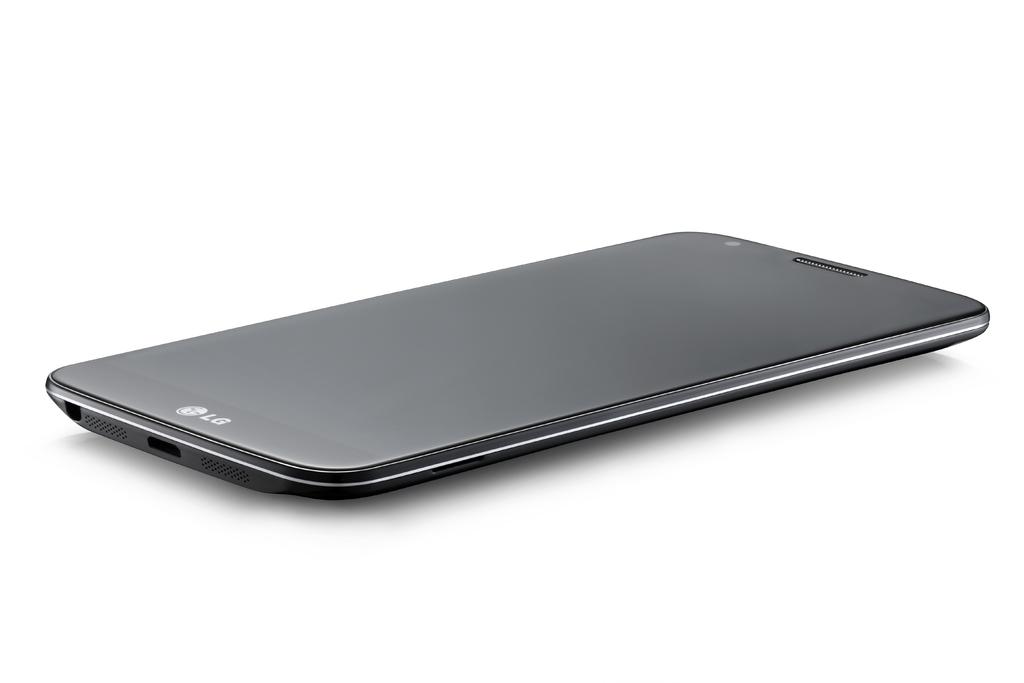What is the brand of the phone?
Offer a very short reply. Lg. 